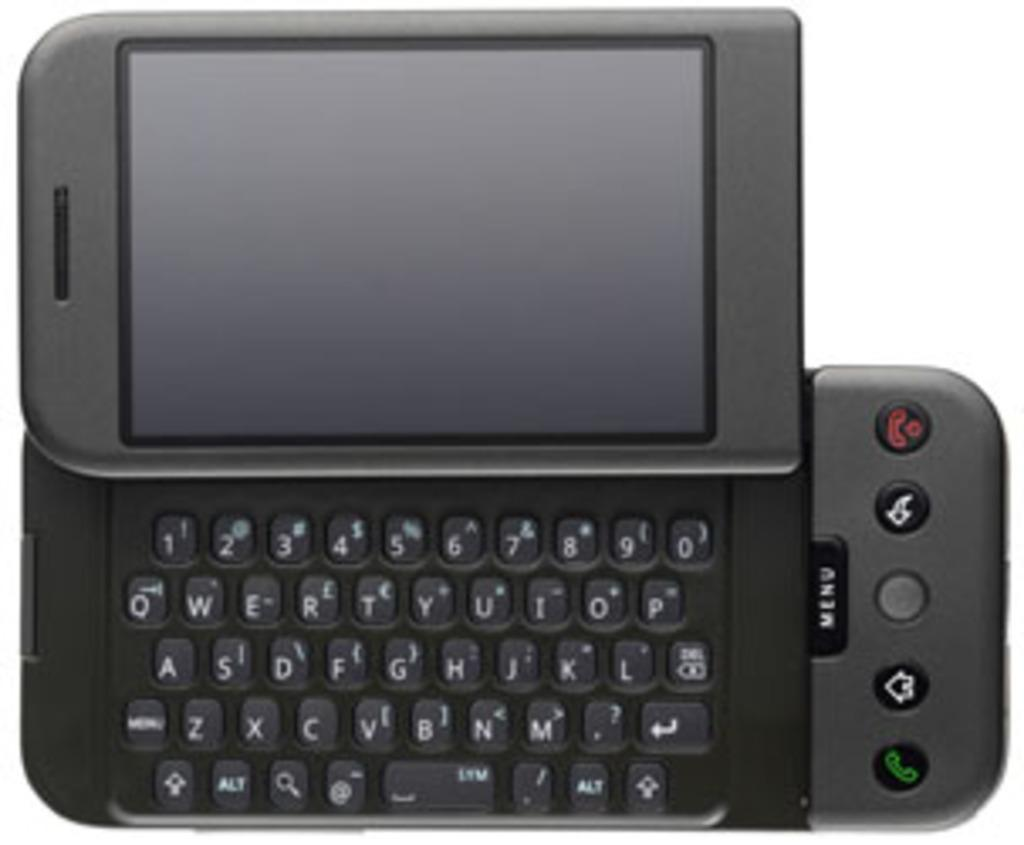<image>
Provide a brief description of the given image. A sliding cell phone with a black menu button at the bottom. 